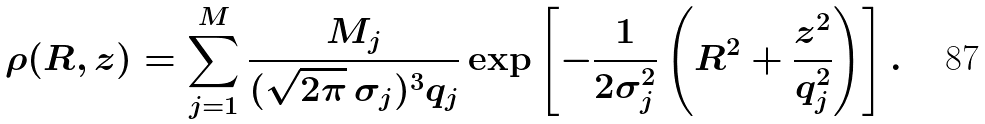Convert formula to latex. <formula><loc_0><loc_0><loc_500><loc_500>\rho ( R , z ) = \sum _ { j = 1 } ^ { M } \frac { M _ { j } } { ( \sqrt { 2 \pi } \, \sigma _ { j } ) ^ { 3 } q _ { j } } \exp \left [ - \frac { 1 } { 2 \sigma _ { j } ^ { 2 } } \left ( R ^ { 2 } + \frac { z ^ { 2 } } { q _ { j } ^ { 2 } } \right ) \right ] .</formula> 